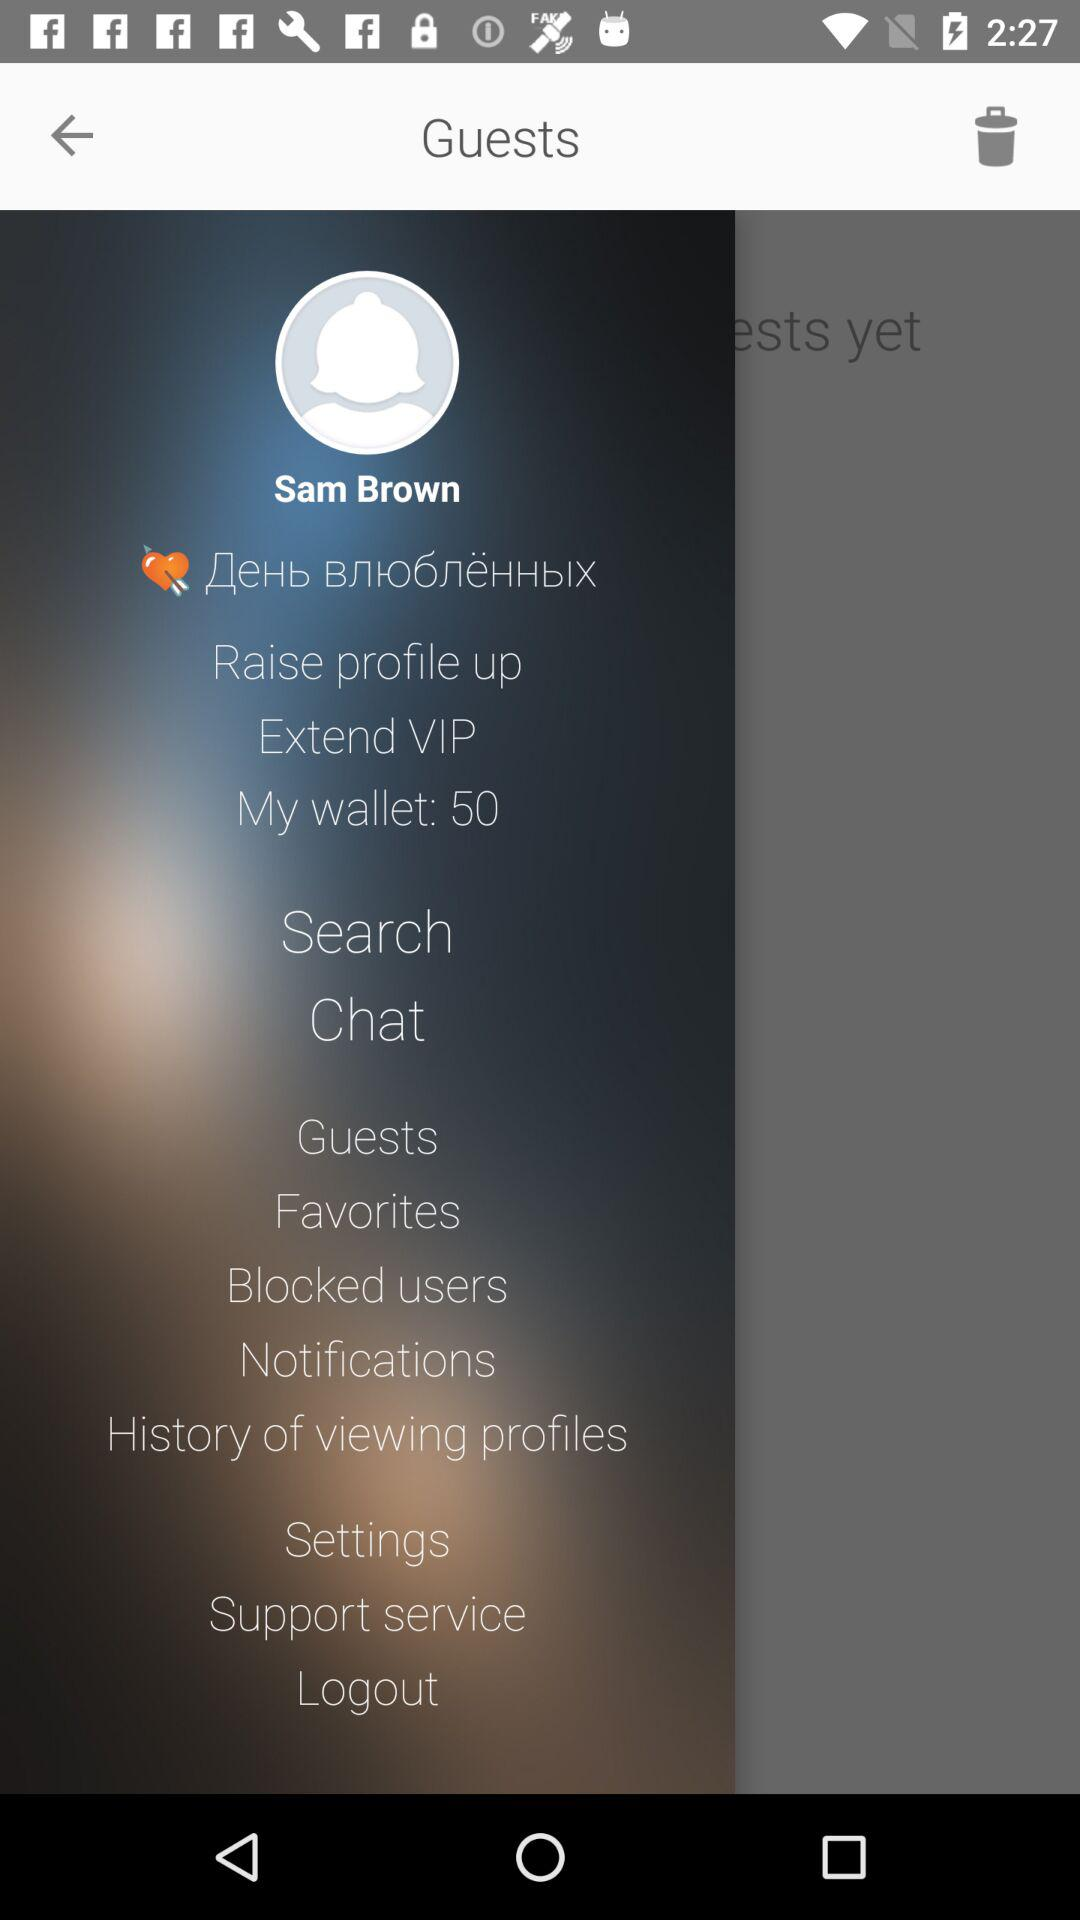What is the profile name? The profile name is Sam Brown. 